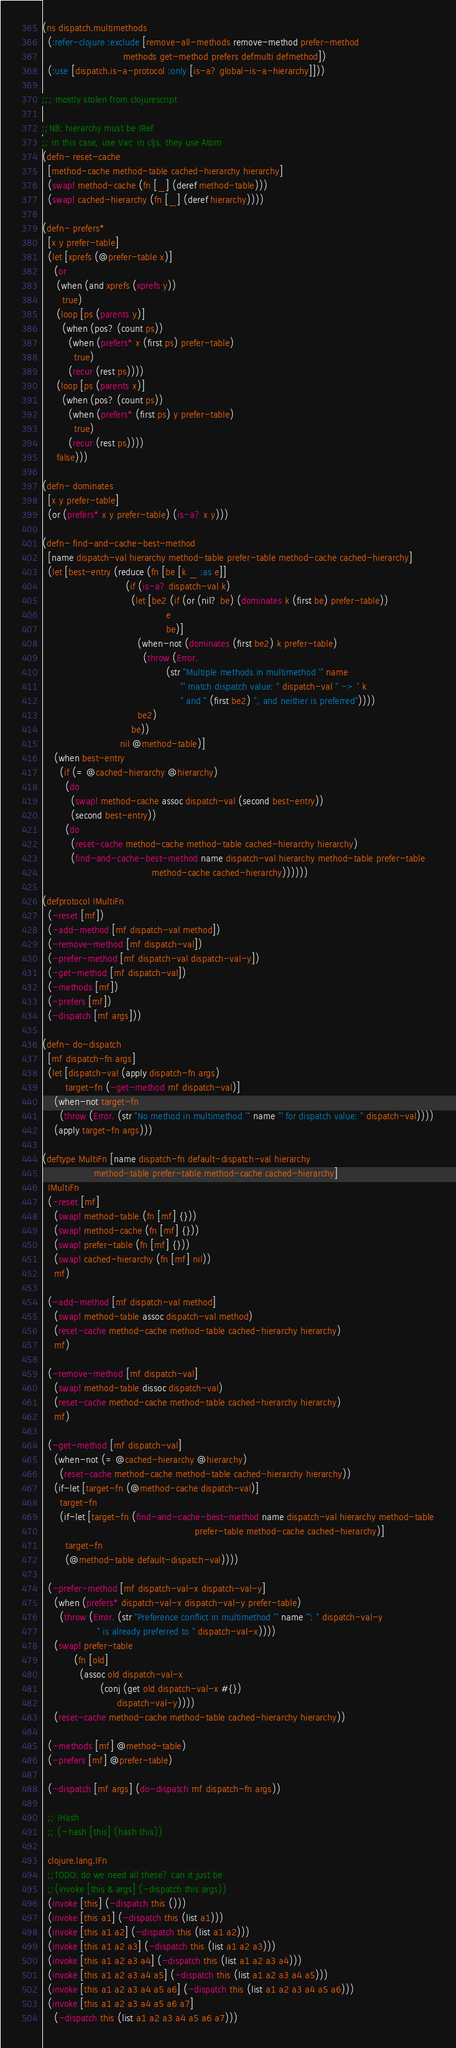Convert code to text. <code><loc_0><loc_0><loc_500><loc_500><_Clojure_>(ns dispatch.multimethods
  (:refer-clojure :exclude [remove-all-methods remove-method prefer-method
                            methods get-method prefers defmulti defmethod])
  (:use [dispatch.is-a-protocol :only [is-a? global-is-a-hierarchy]]))

;;; mostly stolen from clojurescript

;;NB: hierarchy must be IRef
;; in this case, use Var; in cljs, they use Atom
(defn- reset-cache
  [method-cache method-table cached-hierarchy hierarchy]
  (swap! method-cache (fn [_] (deref method-table)))
  (swap! cached-hierarchy (fn [_] (deref hierarchy))))

(defn- prefers*
  [x y prefer-table]
  (let [xprefs (@prefer-table x)]
    (or
     (when (and xprefs (xprefs y))
       true)
     (loop [ps (parents y)]
       (when (pos? (count ps))
         (when (prefers* x (first ps) prefer-table)
           true)
         (recur (rest ps))))
     (loop [ps (parents x)]
       (when (pos? (count ps))
         (when (prefers* (first ps) y prefer-table)
           true)
         (recur (rest ps))))
     false)))

(defn- dominates
  [x y prefer-table]
  (or (prefers* x y prefer-table) (is-a? x y)))

(defn- find-and-cache-best-method
  [name dispatch-val hierarchy method-table prefer-table method-cache cached-hierarchy]
  (let [best-entry (reduce (fn [be [k _ :as e]]
                             (if (is-a? dispatch-val k)
                               (let [be2 (if (or (nil? be) (dominates k (first be) prefer-table))
                                           e
                                           be)]
                                 (when-not (dominates (first be2) k prefer-table)
                                   (throw (Error.
                                           (str "Multiple methods in multimethod '" name
                                                "' match dispatch value: " dispatch-val " -> " k
                                                " and " (first be2) ", and neither is preferred"))))
                                 be2)
                               be))
                           nil @method-table)]
    (when best-entry
      (if (= @cached-hierarchy @hierarchy)
        (do
          (swap! method-cache assoc dispatch-val (second best-entry))
          (second best-entry))
        (do
          (reset-cache method-cache method-table cached-hierarchy hierarchy)
          (find-and-cache-best-method name dispatch-val hierarchy method-table prefer-table
                                      method-cache cached-hierarchy))))))

(defprotocol IMultiFn
  (-reset [mf])
  (-add-method [mf dispatch-val method])
  (-remove-method [mf dispatch-val])
  (-prefer-method [mf dispatch-val dispatch-val-y])
  (-get-method [mf dispatch-val])
  (-methods [mf])
  (-prefers [mf])
  (-dispatch [mf args]))

(defn- do-dispatch
  [mf dispatch-fn args]
  (let [dispatch-val (apply dispatch-fn args)
        target-fn (-get-method mf dispatch-val)]
    (when-not target-fn
      (throw (Error. (str "No method in multimethod '" name "' for dispatch value: " dispatch-val))))
    (apply target-fn args)))

(deftype MultiFn [name dispatch-fn default-dispatch-val hierarchy
                  method-table prefer-table method-cache cached-hierarchy]
  IMultiFn
  (-reset [mf]
    (swap! method-table (fn [mf] {}))
    (swap! method-cache (fn [mf] {}))
    (swap! prefer-table (fn [mf] {}))
    (swap! cached-hierarchy (fn [mf] nil))
    mf)

  (-add-method [mf dispatch-val method]
    (swap! method-table assoc dispatch-val method)
    (reset-cache method-cache method-table cached-hierarchy hierarchy)
    mf)

  (-remove-method [mf dispatch-val]
    (swap! method-table dissoc dispatch-val)
    (reset-cache method-cache method-table cached-hierarchy hierarchy)
    mf)

  (-get-method [mf dispatch-val]
    (when-not (= @cached-hierarchy @hierarchy)
      (reset-cache method-cache method-table cached-hierarchy hierarchy))
    (if-let [target-fn (@method-cache dispatch-val)]
      target-fn
      (if-let [target-fn (find-and-cache-best-method name dispatch-val hierarchy method-table
                                                     prefer-table method-cache cached-hierarchy)]
        target-fn
        (@method-table default-dispatch-val))))

  (-prefer-method [mf dispatch-val-x dispatch-val-y]
    (when (prefers* dispatch-val-x dispatch-val-y prefer-table)
      (throw (Error. (str "Preference conflict in multimethod '" name "': " dispatch-val-y
                   " is already preferred to " dispatch-val-x))))
    (swap! prefer-table
           (fn [old]
             (assoc old dispatch-val-x
                    (conj (get old dispatch-val-x #{})
                          dispatch-val-y))))
    (reset-cache method-cache method-table cached-hierarchy hierarchy))

  (-methods [mf] @method-table)
  (-prefers [mf] @prefer-table)

  (-dispatch [mf args] (do-dispatch mf dispatch-fn args))

  ;; IHash
  ;; (-hash [this] (hash this))

  clojure.lang.IFn
  ;;TODO: do we need all these? can it just be
  ;;(invoke [this & args] (-dispatch this args))
  (invoke [this] (-dispatch this ()))
  (invoke [this a1] (-dispatch this (list a1)))
  (invoke [this a1 a2] (-dispatch this (list a1 a2)))
  (invoke [this a1 a2 a3] (-dispatch this (list a1 a2 a3)))
  (invoke [this a1 a2 a3 a4] (-dispatch this (list a1 a2 a3 a4)))
  (invoke [this a1 a2 a3 a4 a5] (-dispatch this (list a1 a2 a3 a4 a5)))
  (invoke [this a1 a2 a3 a4 a5 a6] (-dispatch this (list a1 a2 a3 a4 a5 a6)))
  (invoke [this a1 a2 a3 a4 a5 a6 a7] 
    (-dispatch this (list a1 a2 a3 a4 a5 a6 a7)))</code> 